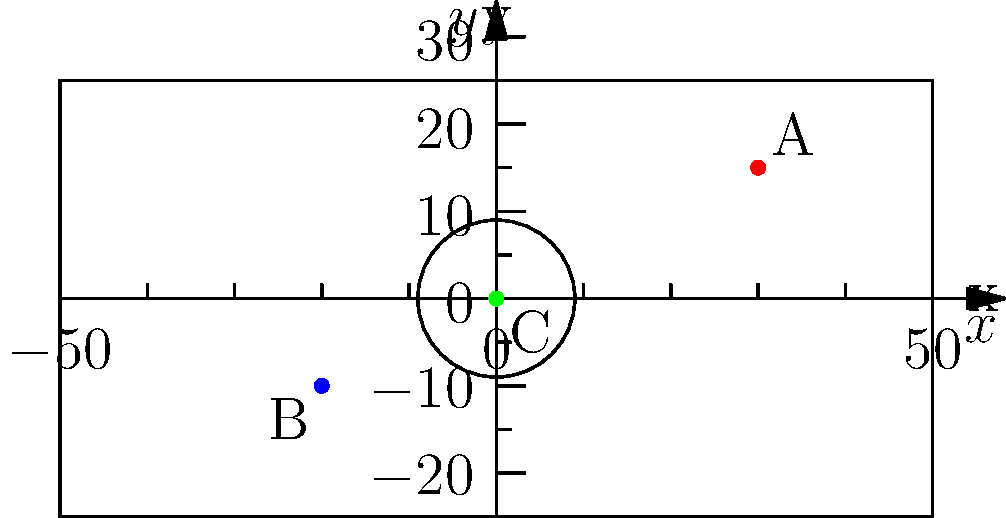In a football match, three key players are positioned on the pitch as shown in the coordinate system above. Player A is at (30, 15), player B is at (-20, -10), and player C is at (0, 0). Calculate the distance between players A and B. To find the distance between two points in a coordinate system, we can use the distance formula:

$$d = \sqrt{(x_2 - x_1)^2 + (y_2 - y_1)^2}$$

Where $(x_1, y_1)$ are the coordinates of the first point and $(x_2, y_2)$ are the coordinates of the second point.

Step 1: Identify the coordinates of players A and B.
Player A: $(x_1, y_1) = (30, 15)$
Player B: $(x_2, y_2) = (-20, -10)$

Step 2: Substitute these values into the distance formula:
$$d = \sqrt{(-20 - 30)^2 + (-10 - 15)^2}$$

Step 3: Simplify the expressions inside the parentheses:
$$d = \sqrt{(-50)^2 + (-25)^2}$$

Step 4: Calculate the squares:
$$d = \sqrt{2500 + 625}$$

Step 5: Add the values under the square root:
$$d = \sqrt{3125}$$

Step 6: Simplify the square root:
$$d = 55.90$$

Therefore, the distance between players A and B is approximately 55.90 units (which would represent meters on a real football pitch).
Answer: 55.90 meters 